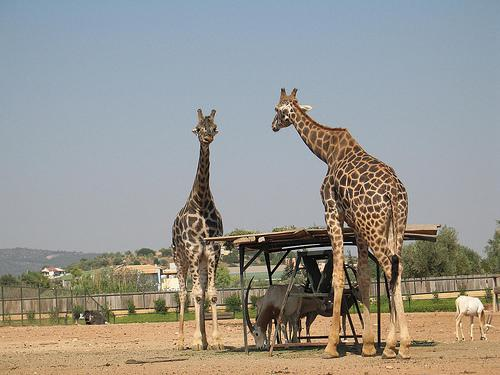What are the two giraffes doing? The two giraffes are facing each other, with one giraffe on the right bending its neck to look at the other giraffe. What type of structure is shading the animals and what materials are used in its construction? A simple wooden structure on top of metal supports shades the animals, with a wooden roof on a metal frame. Give a brief summary of what you see in the image. The image shows two giraffes, goats, a cow, a gazelle, and a wooden fenced area with a simple structure providing shade for the animals. There are green trees in the distance and a clear blue sky above. Which animal is grazing on dried grass and what is unique about its appearance? A white gazelle is grazing on dried grass. It has antlers and a long, curved horn pointing upward. Describe the sky's appearance in the image. The sky is clear, blue, and cloudless. What is the white house in the image like and what color is its roof? The white house is small and has a red roof, sitting in the distance. Describe one giraffe's appearance and what it is doing. A large giraffe with brown, yellow, and square spots on its spotted body, it has a tail and is facing another giraffe while looking away. Mention the position of the trees and how they appear in the image. The green trees are towering over a fence and are located in the distance, with some trees appearing closer on the right side of the image. What kind of environment are the animals in? They are in a national preservation park site with an outdoor enclosure, surrounded by trees and green hills. Identify three objects in the image and describe their features. A white goat has long, curved horns pointing upward. A black cow is laying on the dry ground with pebbles. A wooden fence surrounds the area and runs along the edge of the enclosure. 